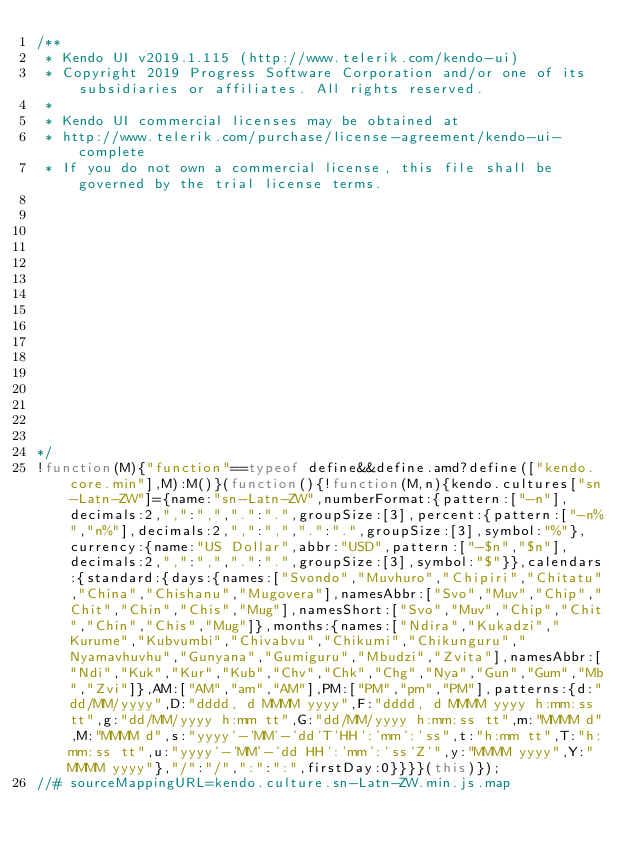Convert code to text. <code><loc_0><loc_0><loc_500><loc_500><_JavaScript_>/** 
 * Kendo UI v2019.1.115 (http://www.telerik.com/kendo-ui)                                                                                                                                               
 * Copyright 2019 Progress Software Corporation and/or one of its subsidiaries or affiliates. All rights reserved.                                                                                      
 *                                                                                                                                                                                                      
 * Kendo UI commercial licenses may be obtained at                                                                                                                                                      
 * http://www.telerik.com/purchase/license-agreement/kendo-ui-complete                                                                                                                                  
 * If you do not own a commercial license, this file shall be governed by the trial license terms.                                                                                                      
                                                                                                                                                                                                       
                                                                                                                                                                                                       
                                                                                                                                                                                                       
                                                                                                                                                                                                       
                                                                                                                                                                                                       
                                                                                                                                                                                                       
                                                                                                                                                                                                       
                                                                                                                                                                                                       
                                                                                                                                                                                                       
                                                                                                                                                                                                       
                                                                                                                                                                                                       
                                                                                                                                                                                                       
                                                                                                                                                                                                       
                                                                                                                                                                                                       
                                                                                                                                                                                                       

*/
!function(M){"function"==typeof define&&define.amd?define(["kendo.core.min"],M):M()}(function(){!function(M,n){kendo.cultures["sn-Latn-ZW"]={name:"sn-Latn-ZW",numberFormat:{pattern:["-n"],decimals:2,",":",",".":".",groupSize:[3],percent:{pattern:["-n%","n%"],decimals:2,",":",",".":".",groupSize:[3],symbol:"%"},currency:{name:"US Dollar",abbr:"USD",pattern:["-$n","$n"],decimals:2,",":",",".":".",groupSize:[3],symbol:"$"}},calendars:{standard:{days:{names:["Svondo","Muvhuro","Chipiri","Chitatu","China","Chishanu","Mugovera"],namesAbbr:["Svo","Muv","Chip","Chit","Chin","Chis","Mug"],namesShort:["Svo","Muv","Chip","Chit","Chin","Chis","Mug"]},months:{names:["Ndira","Kukadzi","Kurume","Kubvumbi","Chivabvu","Chikumi","Chikunguru","Nyamavhuvhu","Gunyana","Gumiguru","Mbudzi","Zvita"],namesAbbr:["Ndi","Kuk","Kur","Kub","Chv","Chk","Chg","Nya","Gun","Gum","Mb","Zvi"]},AM:["AM","am","AM"],PM:["PM","pm","PM"],patterns:{d:"dd/MM/yyyy",D:"dddd, d MMMM yyyy",F:"dddd, d MMMM yyyy h:mm:ss tt",g:"dd/MM/yyyy h:mm tt",G:"dd/MM/yyyy h:mm:ss tt",m:"MMMM d",M:"MMMM d",s:"yyyy'-'MM'-'dd'T'HH':'mm':'ss",t:"h:mm tt",T:"h:mm:ss tt",u:"yyyy'-'MM'-'dd HH':'mm':'ss'Z'",y:"MMMM yyyy",Y:"MMMM yyyy"},"/":"/",":":":",firstDay:0}}}}(this)});
//# sourceMappingURL=kendo.culture.sn-Latn-ZW.min.js.map
</code> 